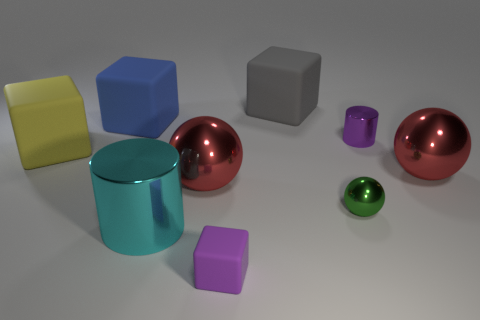What number of big rubber cubes are there? There are two large rubber cubes visible in the image. They can be distinguished by their shape and matt texture, which contrasts with the shiny surface of the spheres and cylinder. 